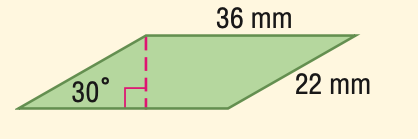Answer the mathemtical geometry problem and directly provide the correct option letter.
Question: Find the area of the parallelogram.
Choices: A: 396 B: 560.0 C: 685.9 D: 792 A 